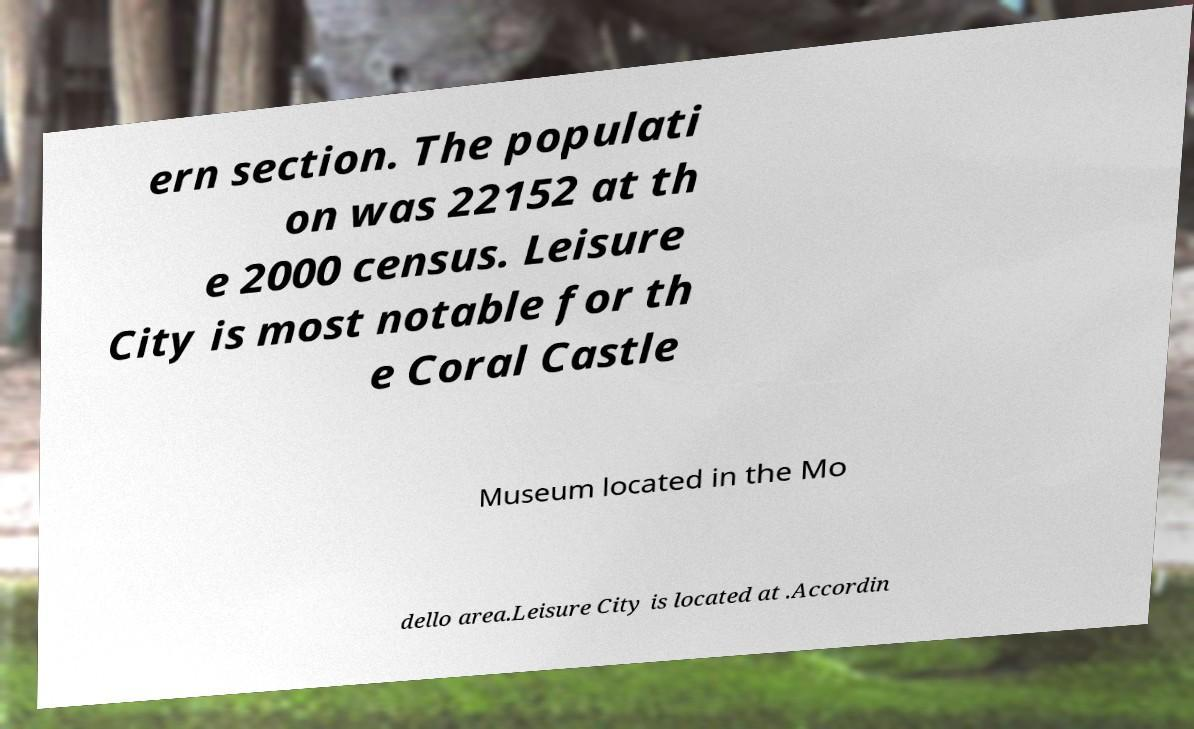What messages or text are displayed in this image? I need them in a readable, typed format. ern section. The populati on was 22152 at th e 2000 census. Leisure City is most notable for th e Coral Castle Museum located in the Mo dello area.Leisure City is located at .Accordin 